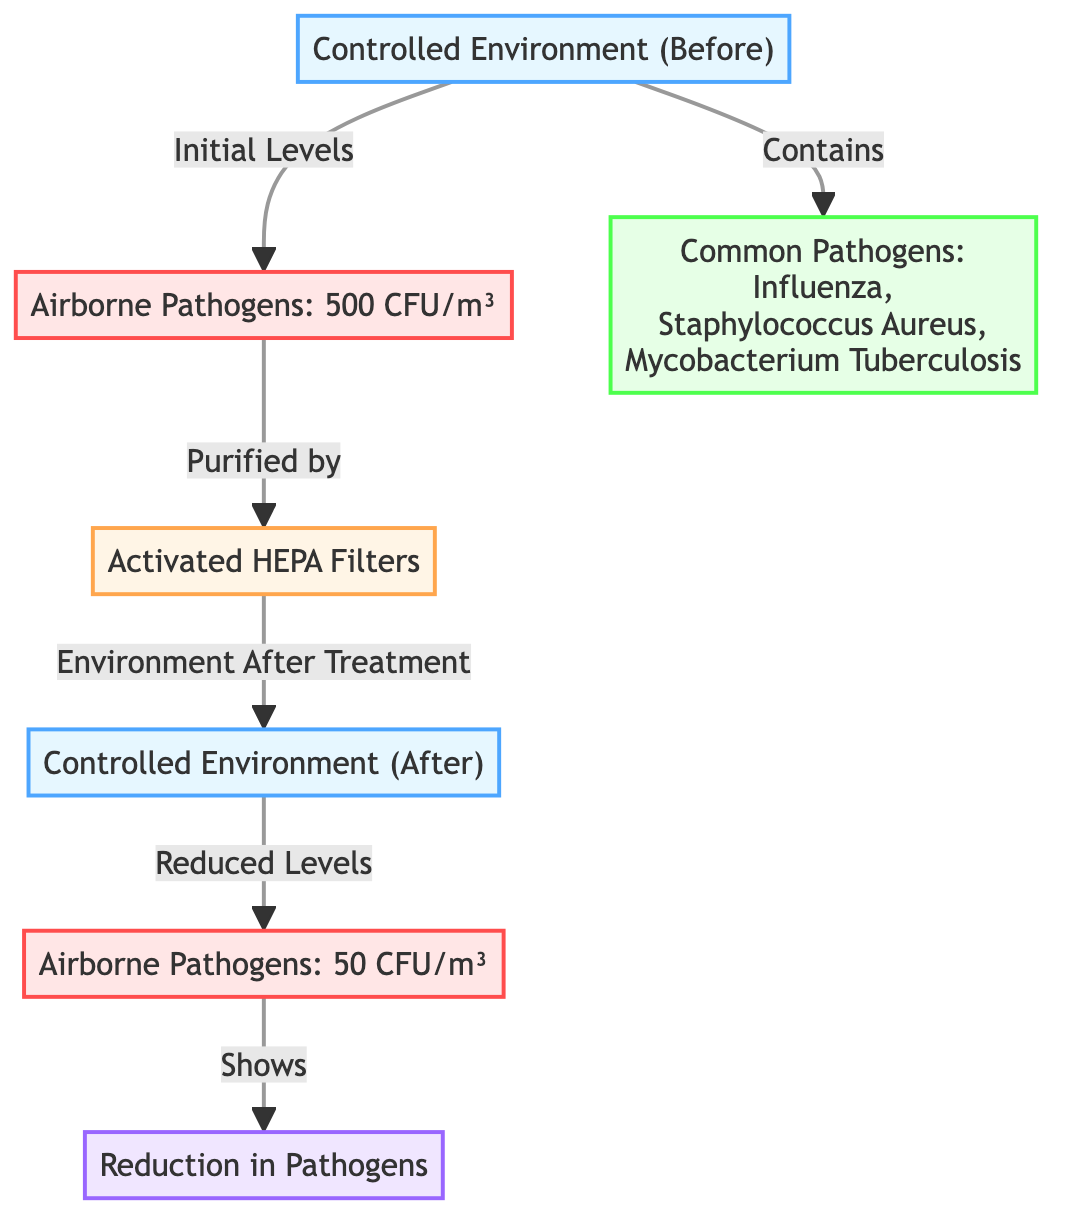What was the initial level of airborne pathogens? The diagram specifies that the initial level of airborne pathogens in the controlled environment before the air purification system was 500 CFU/m³, which can be directly found in the node labeled "Airborne Pathogens: 500 CFU/m³".
Answer: 500 CFU/m³ What type of pathogens are listed in the diagram? The diagram indicates that the common pathogens present before purification include Influenza, Staphylococcus Aureus, and Mycobacterium Tuberculosis, which is detailed in the node labeled "Common Pathogens".
Answer: Influenza, Staphylococcus Aureus, Mycobacterium Tuberculosis What purification system is mentioned in the diagram? The diagram clearly states "Activated HEPA Filters" as the purification system used to reduce airborne pathogens, located in the node labeled "Activated HEPA Filters".
Answer: Activated HEPA Filters What were the airborne pathogen levels after purification? According to the node labeled "Airborne Pathogens: 50 CFU/m³", the diagram shows that after the purification process, the levels of airborne pathogens were reduced to 50 CFU/m³.
Answer: 50 CFU/m³ How much was the reduction in airborne pathogens? By comparing the initial level of 500 CFU/m³ to the final level of 50 CFU/m³, the reduction can be calculated as 500 CFU/m³ - 50 CFU/m³, resulting in a total reduction of 450 CFU/m³.
Answer: 450 CFU/m³ What indicates the effectiveness of the purification system? The diagram shows a node labeled "Reduction in Pathogens", which signifies the impact or effectiveness of the air purification system in lowering airborne pathogens, demonstrated as a connection from the reduced levels to this impact node.
Answer: Reduction in Pathogens How many nodes are associated with the "Controlled Environment" in the diagram? There are two nodes labeled "Controlled Environment": one for before the air purification system and another for after the treatment. Therefore, the total number of nodes associated with "Controlled Environment" is two.
Answer: 2 What is the relationship between airborne pathogens and the purification system? The diagram illustrates a direct relationship that the airborne pathogens are purified by the activated HEPA filters, indicated by the line connecting the nodes "Airborne Pathogens: 500 CFU/m³" and "Activated HEPA Filters".
Answer: Purified by 